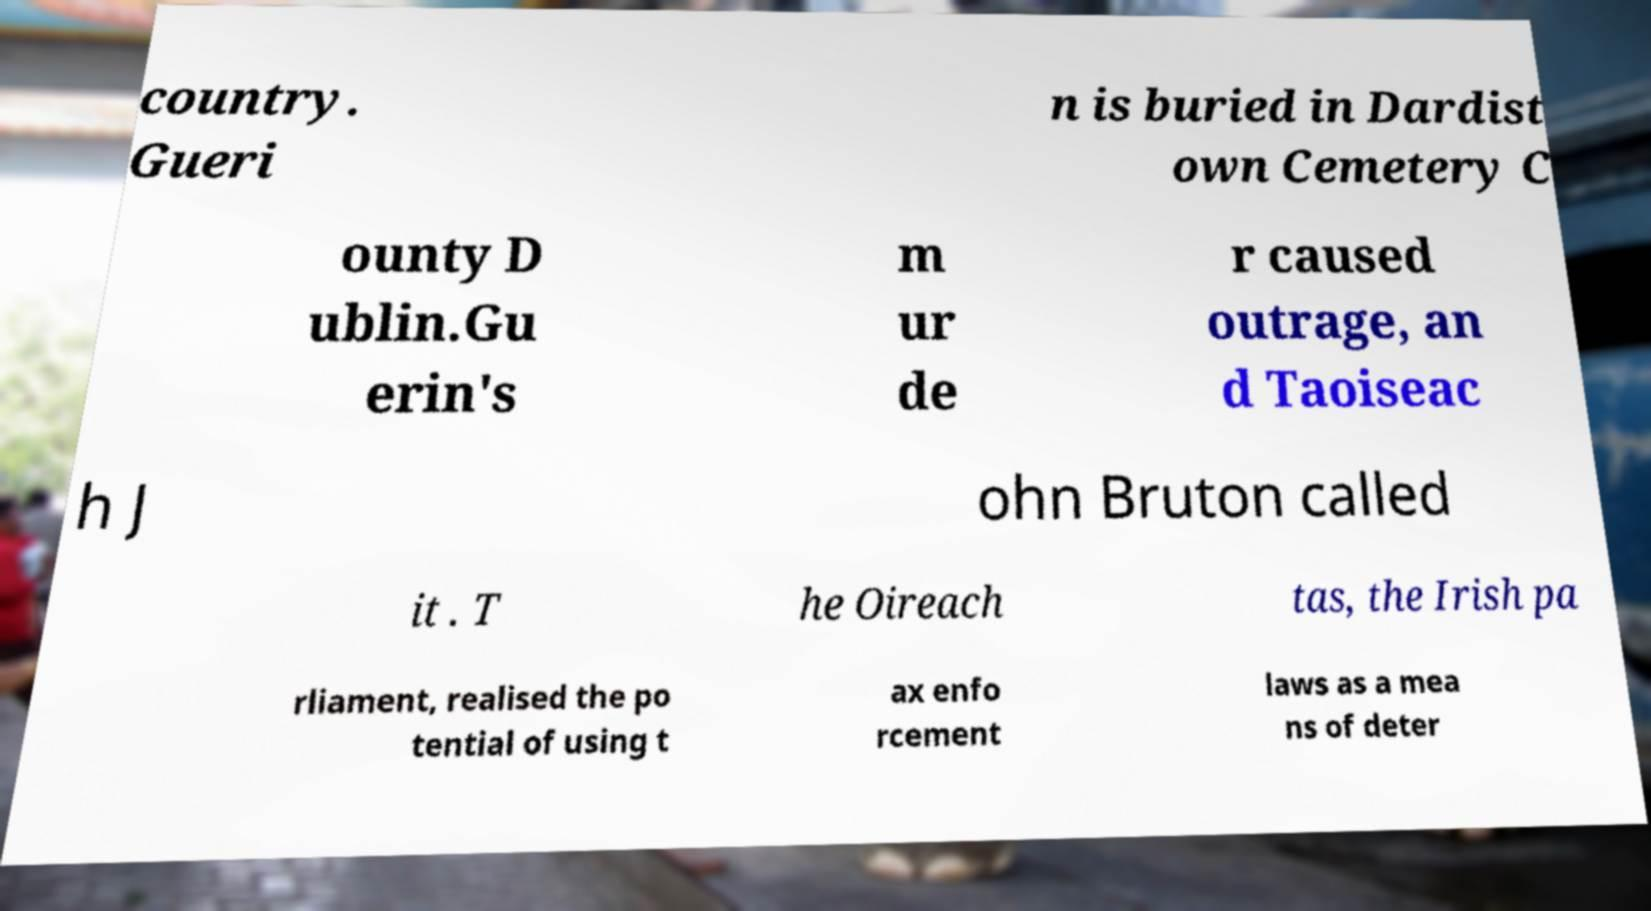I need the written content from this picture converted into text. Can you do that? country. Gueri n is buried in Dardist own Cemetery C ounty D ublin.Gu erin's m ur de r caused outrage, an d Taoiseac h J ohn Bruton called it . T he Oireach tas, the Irish pa rliament, realised the po tential of using t ax enfo rcement laws as a mea ns of deter 